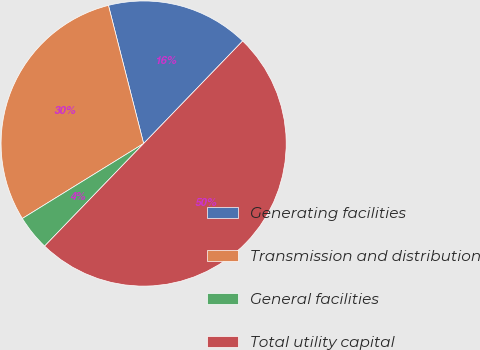Convert chart to OTSL. <chart><loc_0><loc_0><loc_500><loc_500><pie_chart><fcel>Generating facilities<fcel>Transmission and distribution<fcel>General facilities<fcel>Total utility capital<nl><fcel>16.19%<fcel>29.84%<fcel>3.97%<fcel>50.0%<nl></chart> 